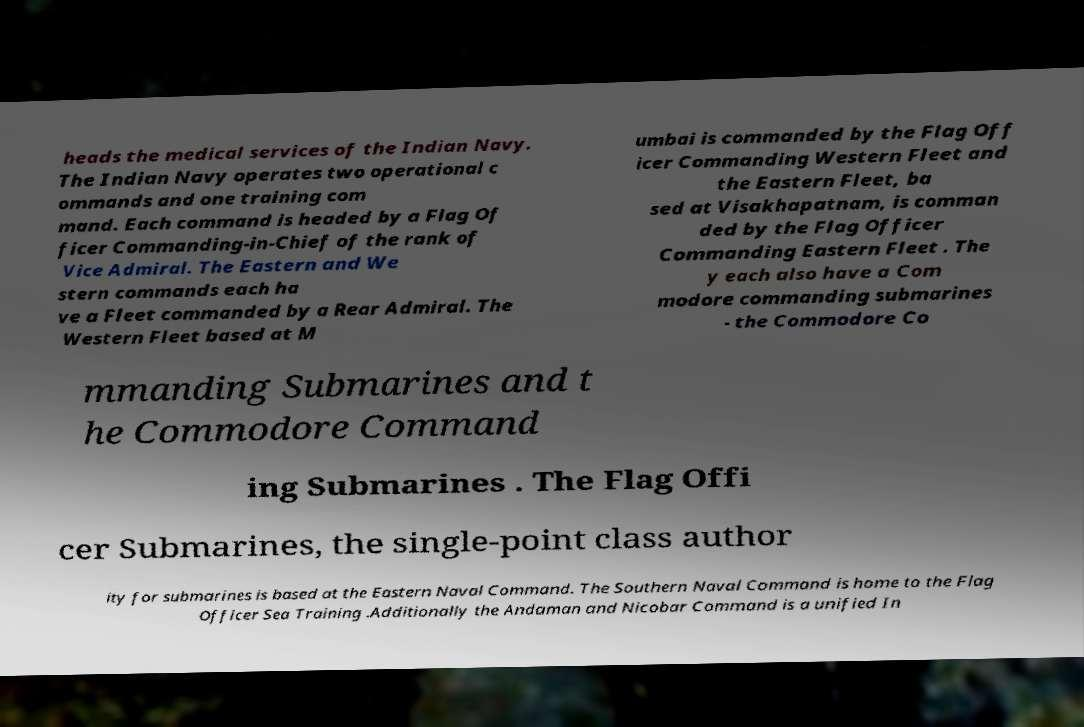Can you read and provide the text displayed in the image?This photo seems to have some interesting text. Can you extract and type it out for me? heads the medical services of the Indian Navy. The Indian Navy operates two operational c ommands and one training com mand. Each command is headed by a Flag Of ficer Commanding-in-Chief of the rank of Vice Admiral. The Eastern and We stern commands each ha ve a Fleet commanded by a Rear Admiral. The Western Fleet based at M umbai is commanded by the Flag Off icer Commanding Western Fleet and the Eastern Fleet, ba sed at Visakhapatnam, is comman ded by the Flag Officer Commanding Eastern Fleet . The y each also have a Com modore commanding submarines - the Commodore Co mmanding Submarines and t he Commodore Command ing Submarines . The Flag Offi cer Submarines, the single-point class author ity for submarines is based at the Eastern Naval Command. The Southern Naval Command is home to the Flag Officer Sea Training .Additionally the Andaman and Nicobar Command is a unified In 